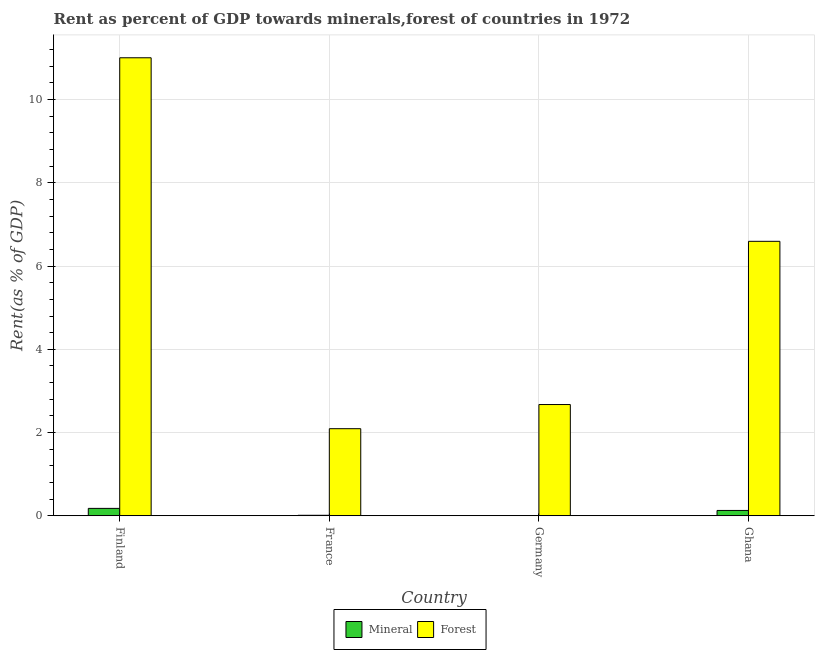How many different coloured bars are there?
Your response must be concise. 2. Are the number of bars on each tick of the X-axis equal?
Provide a short and direct response. Yes. What is the label of the 4th group of bars from the left?
Offer a terse response. Ghana. What is the mineral rent in France?
Keep it short and to the point. 0.01. Across all countries, what is the maximum forest rent?
Provide a short and direct response. 11.01. Across all countries, what is the minimum mineral rent?
Offer a very short reply. 0. What is the total mineral rent in the graph?
Your answer should be very brief. 0.32. What is the difference between the forest rent in Germany and that in Ghana?
Ensure brevity in your answer.  -3.92. What is the difference between the mineral rent in Germany and the forest rent in Finland?
Give a very brief answer. -11. What is the average forest rent per country?
Provide a short and direct response. 5.59. What is the difference between the mineral rent and forest rent in Finland?
Your answer should be compact. -10.83. What is the ratio of the mineral rent in Finland to that in Ghana?
Your answer should be very brief. 1.38. Is the difference between the forest rent in Finland and France greater than the difference between the mineral rent in Finland and France?
Ensure brevity in your answer.  Yes. What is the difference between the highest and the second highest mineral rent?
Your answer should be very brief. 0.05. What is the difference between the highest and the lowest forest rent?
Ensure brevity in your answer.  8.91. In how many countries, is the forest rent greater than the average forest rent taken over all countries?
Give a very brief answer. 2. What does the 2nd bar from the left in Germany represents?
Offer a very short reply. Forest. What does the 2nd bar from the right in Ghana represents?
Your response must be concise. Mineral. How many bars are there?
Give a very brief answer. 8. Are all the bars in the graph horizontal?
Give a very brief answer. No. What is the difference between two consecutive major ticks on the Y-axis?
Offer a terse response. 2. How many legend labels are there?
Give a very brief answer. 2. What is the title of the graph?
Ensure brevity in your answer.  Rent as percent of GDP towards minerals,forest of countries in 1972. Does "Researchers" appear as one of the legend labels in the graph?
Offer a terse response. No. What is the label or title of the Y-axis?
Offer a terse response. Rent(as % of GDP). What is the Rent(as % of GDP) of Mineral in Finland?
Offer a terse response. 0.18. What is the Rent(as % of GDP) of Forest in Finland?
Offer a very short reply. 11.01. What is the Rent(as % of GDP) of Mineral in France?
Ensure brevity in your answer.  0.01. What is the Rent(as % of GDP) of Forest in France?
Provide a short and direct response. 2.09. What is the Rent(as % of GDP) of Mineral in Germany?
Offer a terse response. 0. What is the Rent(as % of GDP) in Forest in Germany?
Make the answer very short. 2.67. What is the Rent(as % of GDP) in Mineral in Ghana?
Provide a succinct answer. 0.13. What is the Rent(as % of GDP) of Forest in Ghana?
Make the answer very short. 6.6. Across all countries, what is the maximum Rent(as % of GDP) in Mineral?
Ensure brevity in your answer.  0.18. Across all countries, what is the maximum Rent(as % of GDP) of Forest?
Provide a short and direct response. 11.01. Across all countries, what is the minimum Rent(as % of GDP) in Mineral?
Your answer should be compact. 0. Across all countries, what is the minimum Rent(as % of GDP) in Forest?
Your answer should be compact. 2.09. What is the total Rent(as % of GDP) in Mineral in the graph?
Give a very brief answer. 0.32. What is the total Rent(as % of GDP) in Forest in the graph?
Your answer should be very brief. 22.37. What is the difference between the Rent(as % of GDP) in Mineral in Finland and that in France?
Ensure brevity in your answer.  0.17. What is the difference between the Rent(as % of GDP) in Forest in Finland and that in France?
Provide a succinct answer. 8.91. What is the difference between the Rent(as % of GDP) in Mineral in Finland and that in Germany?
Your response must be concise. 0.17. What is the difference between the Rent(as % of GDP) in Forest in Finland and that in Germany?
Keep it short and to the point. 8.33. What is the difference between the Rent(as % of GDP) in Mineral in Finland and that in Ghana?
Keep it short and to the point. 0.05. What is the difference between the Rent(as % of GDP) in Forest in Finland and that in Ghana?
Give a very brief answer. 4.41. What is the difference between the Rent(as % of GDP) of Mineral in France and that in Germany?
Your answer should be compact. 0.01. What is the difference between the Rent(as % of GDP) in Forest in France and that in Germany?
Your answer should be compact. -0.58. What is the difference between the Rent(as % of GDP) in Mineral in France and that in Ghana?
Give a very brief answer. -0.12. What is the difference between the Rent(as % of GDP) of Forest in France and that in Ghana?
Keep it short and to the point. -4.5. What is the difference between the Rent(as % of GDP) of Mineral in Germany and that in Ghana?
Provide a succinct answer. -0.12. What is the difference between the Rent(as % of GDP) in Forest in Germany and that in Ghana?
Ensure brevity in your answer.  -3.92. What is the difference between the Rent(as % of GDP) in Mineral in Finland and the Rent(as % of GDP) in Forest in France?
Offer a terse response. -1.91. What is the difference between the Rent(as % of GDP) of Mineral in Finland and the Rent(as % of GDP) of Forest in Germany?
Make the answer very short. -2.5. What is the difference between the Rent(as % of GDP) of Mineral in Finland and the Rent(as % of GDP) of Forest in Ghana?
Provide a succinct answer. -6.42. What is the difference between the Rent(as % of GDP) of Mineral in France and the Rent(as % of GDP) of Forest in Germany?
Your response must be concise. -2.66. What is the difference between the Rent(as % of GDP) of Mineral in France and the Rent(as % of GDP) of Forest in Ghana?
Your response must be concise. -6.58. What is the difference between the Rent(as % of GDP) in Mineral in Germany and the Rent(as % of GDP) in Forest in Ghana?
Your answer should be compact. -6.59. What is the average Rent(as % of GDP) of Mineral per country?
Ensure brevity in your answer.  0.08. What is the average Rent(as % of GDP) of Forest per country?
Make the answer very short. 5.59. What is the difference between the Rent(as % of GDP) in Mineral and Rent(as % of GDP) in Forest in Finland?
Make the answer very short. -10.83. What is the difference between the Rent(as % of GDP) of Mineral and Rent(as % of GDP) of Forest in France?
Provide a short and direct response. -2.08. What is the difference between the Rent(as % of GDP) of Mineral and Rent(as % of GDP) of Forest in Germany?
Ensure brevity in your answer.  -2.67. What is the difference between the Rent(as % of GDP) in Mineral and Rent(as % of GDP) in Forest in Ghana?
Your response must be concise. -6.47. What is the ratio of the Rent(as % of GDP) in Mineral in Finland to that in France?
Ensure brevity in your answer.  14.61. What is the ratio of the Rent(as % of GDP) of Forest in Finland to that in France?
Your answer should be compact. 5.26. What is the ratio of the Rent(as % of GDP) of Mineral in Finland to that in Germany?
Your response must be concise. 42.51. What is the ratio of the Rent(as % of GDP) of Forest in Finland to that in Germany?
Offer a very short reply. 4.12. What is the ratio of the Rent(as % of GDP) of Mineral in Finland to that in Ghana?
Offer a terse response. 1.38. What is the ratio of the Rent(as % of GDP) of Forest in Finland to that in Ghana?
Provide a short and direct response. 1.67. What is the ratio of the Rent(as % of GDP) of Mineral in France to that in Germany?
Provide a succinct answer. 2.91. What is the ratio of the Rent(as % of GDP) in Forest in France to that in Germany?
Make the answer very short. 0.78. What is the ratio of the Rent(as % of GDP) in Mineral in France to that in Ghana?
Your response must be concise. 0.09. What is the ratio of the Rent(as % of GDP) of Forest in France to that in Ghana?
Provide a short and direct response. 0.32. What is the ratio of the Rent(as % of GDP) in Mineral in Germany to that in Ghana?
Your response must be concise. 0.03. What is the ratio of the Rent(as % of GDP) in Forest in Germany to that in Ghana?
Your response must be concise. 0.41. What is the difference between the highest and the second highest Rent(as % of GDP) in Mineral?
Ensure brevity in your answer.  0.05. What is the difference between the highest and the second highest Rent(as % of GDP) in Forest?
Provide a succinct answer. 4.41. What is the difference between the highest and the lowest Rent(as % of GDP) in Mineral?
Offer a very short reply. 0.17. What is the difference between the highest and the lowest Rent(as % of GDP) in Forest?
Your answer should be compact. 8.91. 